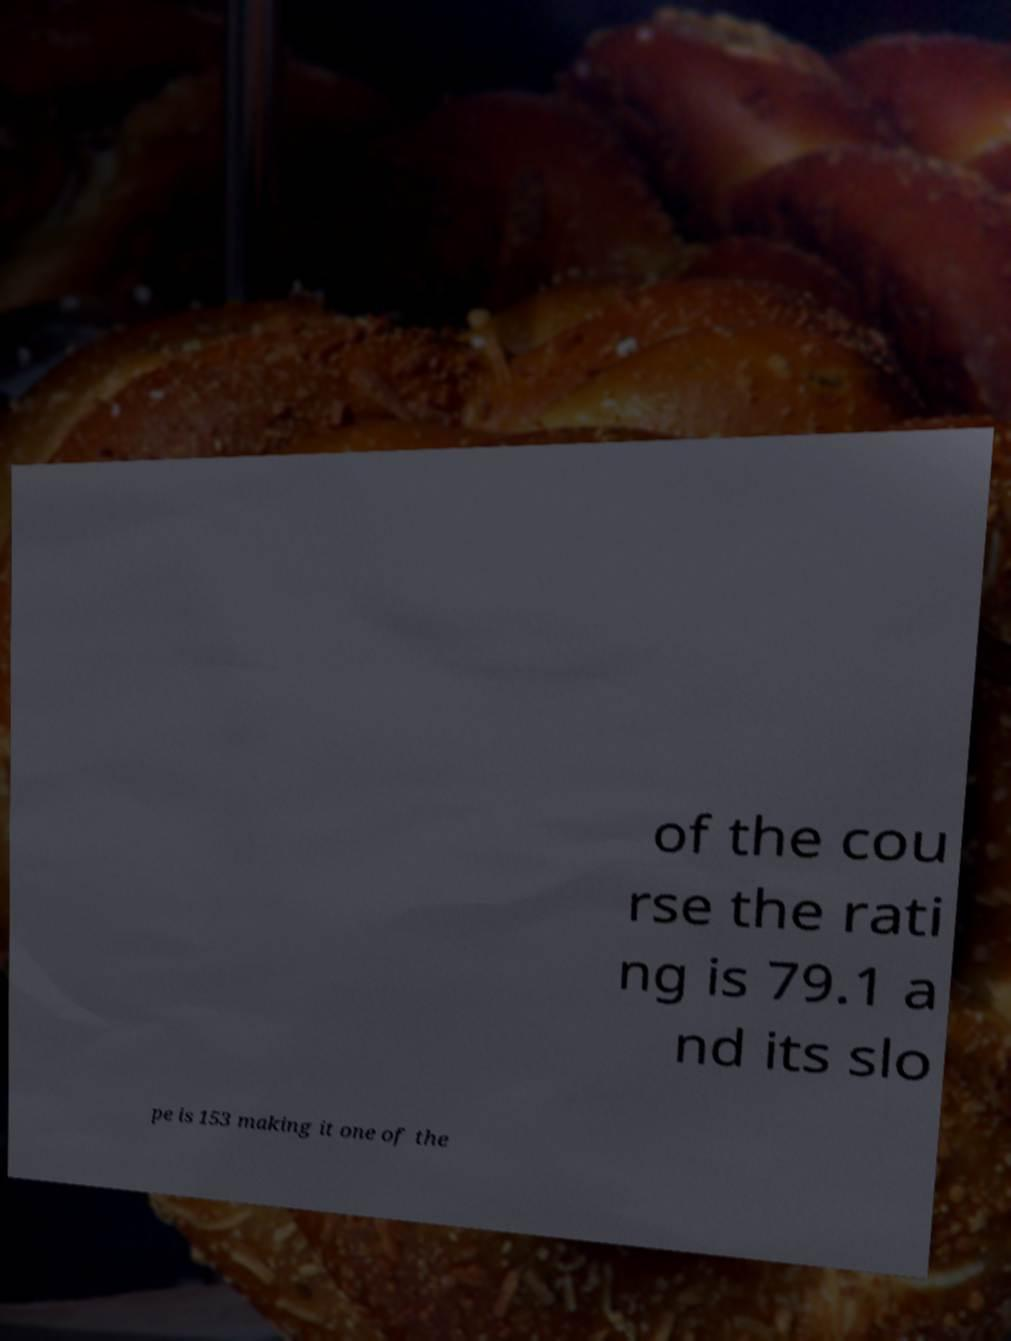For documentation purposes, I need the text within this image transcribed. Could you provide that? of the cou rse the rati ng is 79.1 a nd its slo pe is 153 making it one of the 